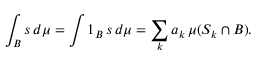<formula> <loc_0><loc_0><loc_500><loc_500>\int _ { B } s \, d \mu = \int 1 _ { B } \, s \, d \mu = \sum _ { k } a _ { k } \, \mu ( S _ { k } \cap B ) .</formula> 